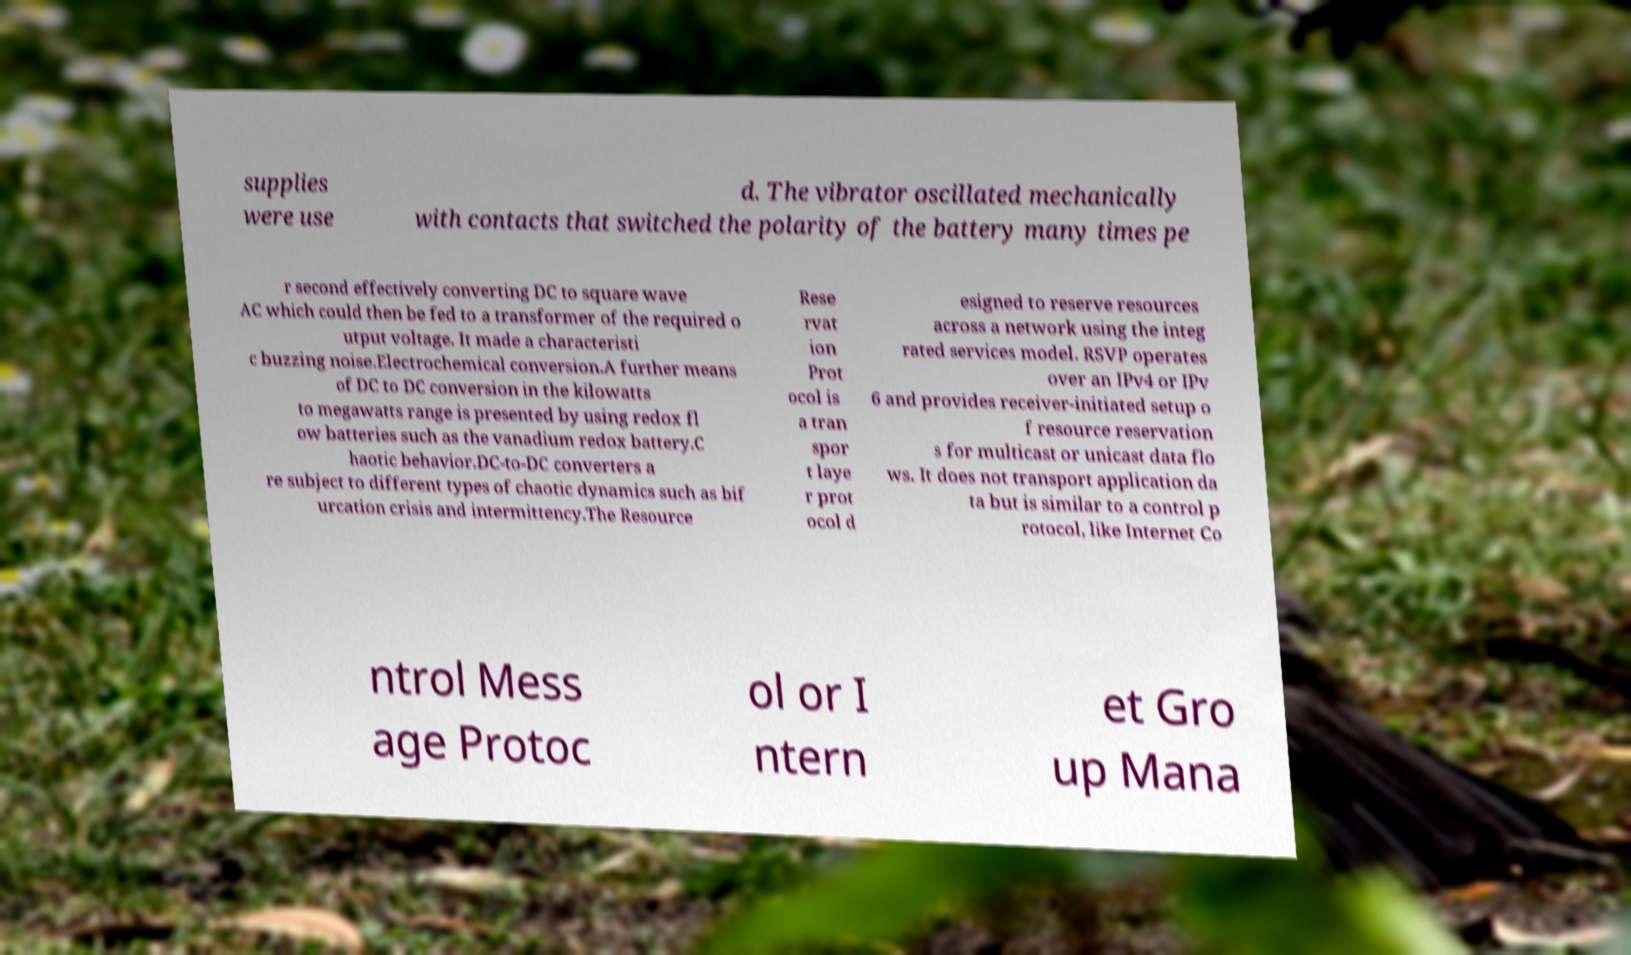There's text embedded in this image that I need extracted. Can you transcribe it verbatim? supplies were use d. The vibrator oscillated mechanically with contacts that switched the polarity of the battery many times pe r second effectively converting DC to square wave AC which could then be fed to a transformer of the required o utput voltage. It made a characteristi c buzzing noise.Electrochemical conversion.A further means of DC to DC conversion in the kilowatts to megawatts range is presented by using redox fl ow batteries such as the vanadium redox battery.C haotic behavior.DC-to-DC converters a re subject to different types of chaotic dynamics such as bif urcation crisis and intermittency.The Resource Rese rvat ion Prot ocol is a tran spor t laye r prot ocol d esigned to reserve resources across a network using the integ rated services model. RSVP operates over an IPv4 or IPv 6 and provides receiver-initiated setup o f resource reservation s for multicast or unicast data flo ws. It does not transport application da ta but is similar to a control p rotocol, like Internet Co ntrol Mess age Protoc ol or I ntern et Gro up Mana 